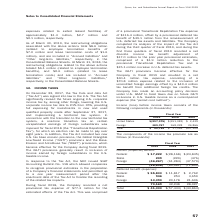From Qorvo's financial document, What are the company's respective loss before income taxes from the United States in 2018 and 2019? The document shows two values: 151,083 and 297,975 (in thousands). From the document: "United States $(297,975) $(151,083) $ 2,439 United States $(297,975) $(151,083) $ 2,439..." Also, What are the company's respective foreign income before taxes in 2018 and 2019? The document shows two values: 168,228 and 389,767 (in thousands). From the document: "Foreign 389,767 168,228 24,866 Foreign 389,767 168,228 24,866..." Also, What are the company's respective total income before income taxes in 2018 and 2019? The document shows two values: 17,145 and 91,792 (in thousands). From the document: "Total $ 91,792 $ 17,145 $27,305 Total $ 91,792 $ 17,145 $27,305..." Also, can you calculate: What is the company's average loss before income taxes from the United States in 2018 and 2019? To answer this question, I need to perform calculations using the financial data. The calculation is: (151,083 + 297,975)/2 , which equals 224529 (in thousands). This is based on the information: "United States $(297,975) $(151,083) $ 2,439 United States $(297,975) $(151,083) $ 2,439..." The key data points involved are: 151,083, 297,975. Also, can you calculate: What is the company's average foreign income before taxes in 2018 and 2019? To answer this question, I need to perform calculations using the financial data. The calculation is: (168,228 + 389,767)/2 , which equals 278997.5 (in thousands). This is based on the information: "Foreign 389,767 168,228 24,866 Foreign 389,767 168,228 24,866..." The key data points involved are: 168,228, 389,767. Also, can you calculate: What is the company's average total income before income taxes in 2018 and 2019? To answer this question, I need to perform calculations using the financial data. The calculation is: (17,145 + 91,792)/2 , which equals 54468.5 (in thousands). This is based on the information: "Total $ 91,792 $ 17,145 $27,305 Total $ 91,792 $ 17,145 $27,305..." The key data points involved are: 17,145, 91,792. 